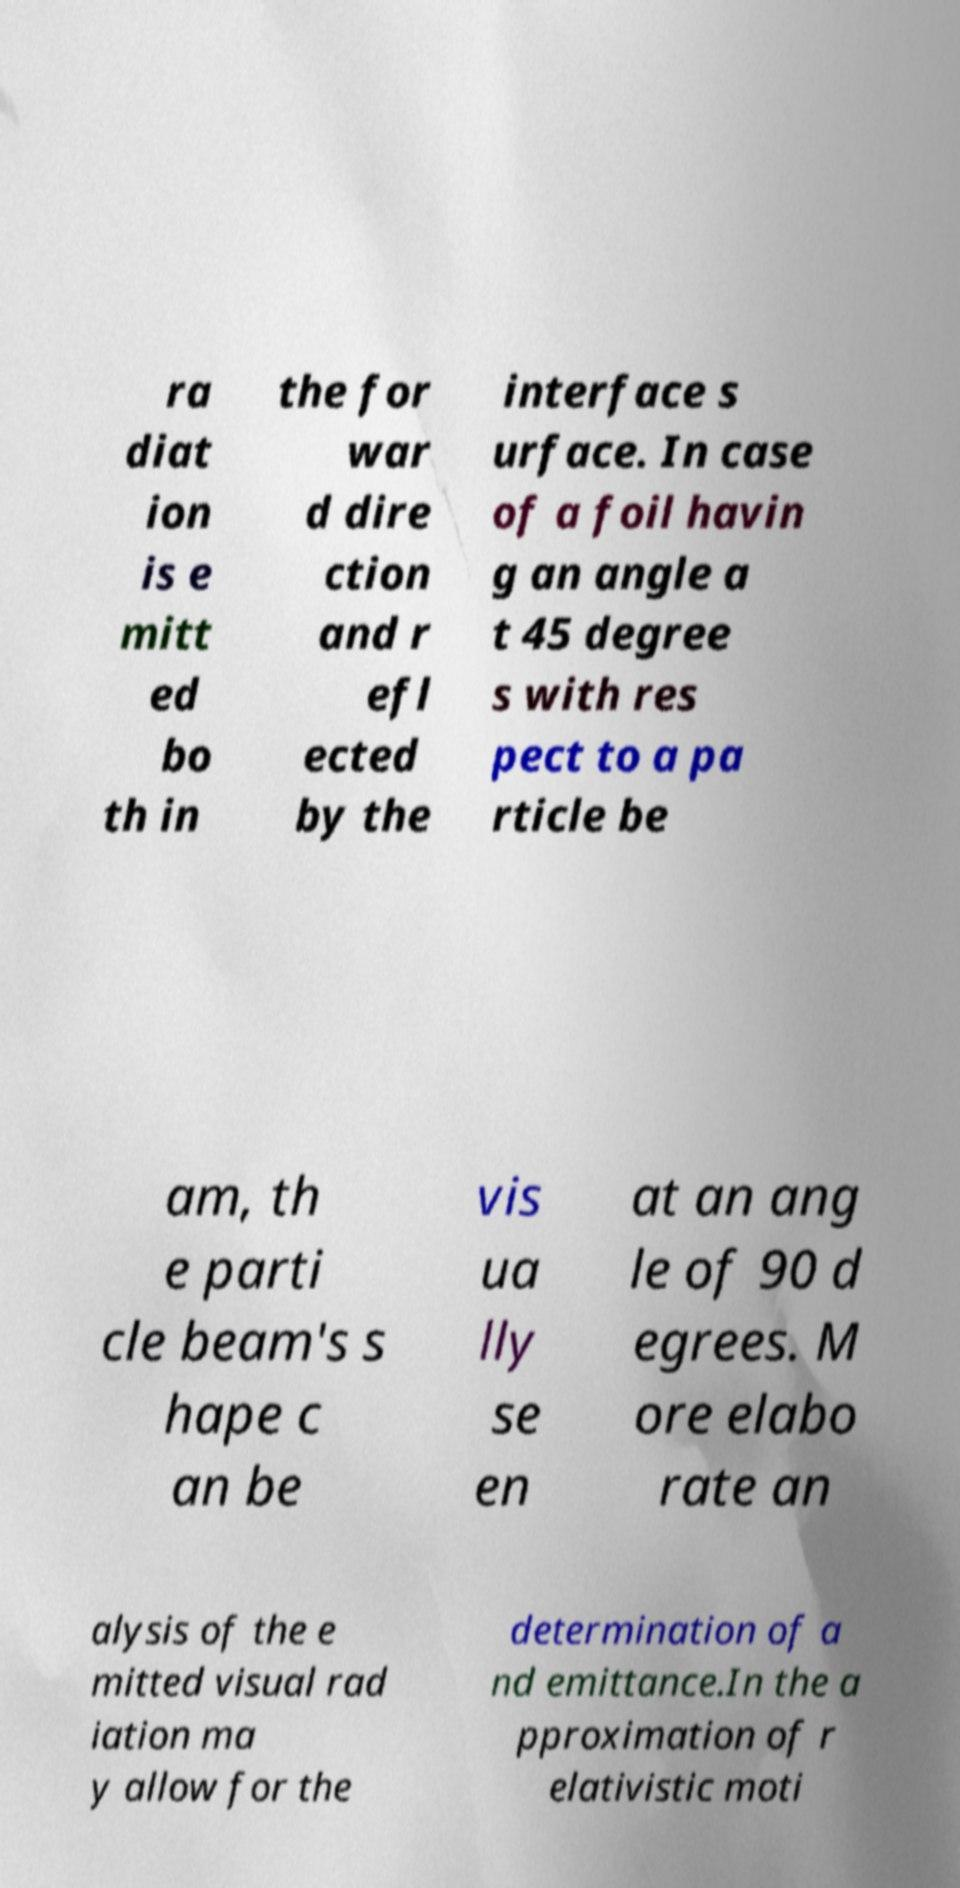Could you assist in decoding the text presented in this image and type it out clearly? ra diat ion is e mitt ed bo th in the for war d dire ction and r efl ected by the interface s urface. In case of a foil havin g an angle a t 45 degree s with res pect to a pa rticle be am, th e parti cle beam's s hape c an be vis ua lly se en at an ang le of 90 d egrees. M ore elabo rate an alysis of the e mitted visual rad iation ma y allow for the determination of a nd emittance.In the a pproximation of r elativistic moti 